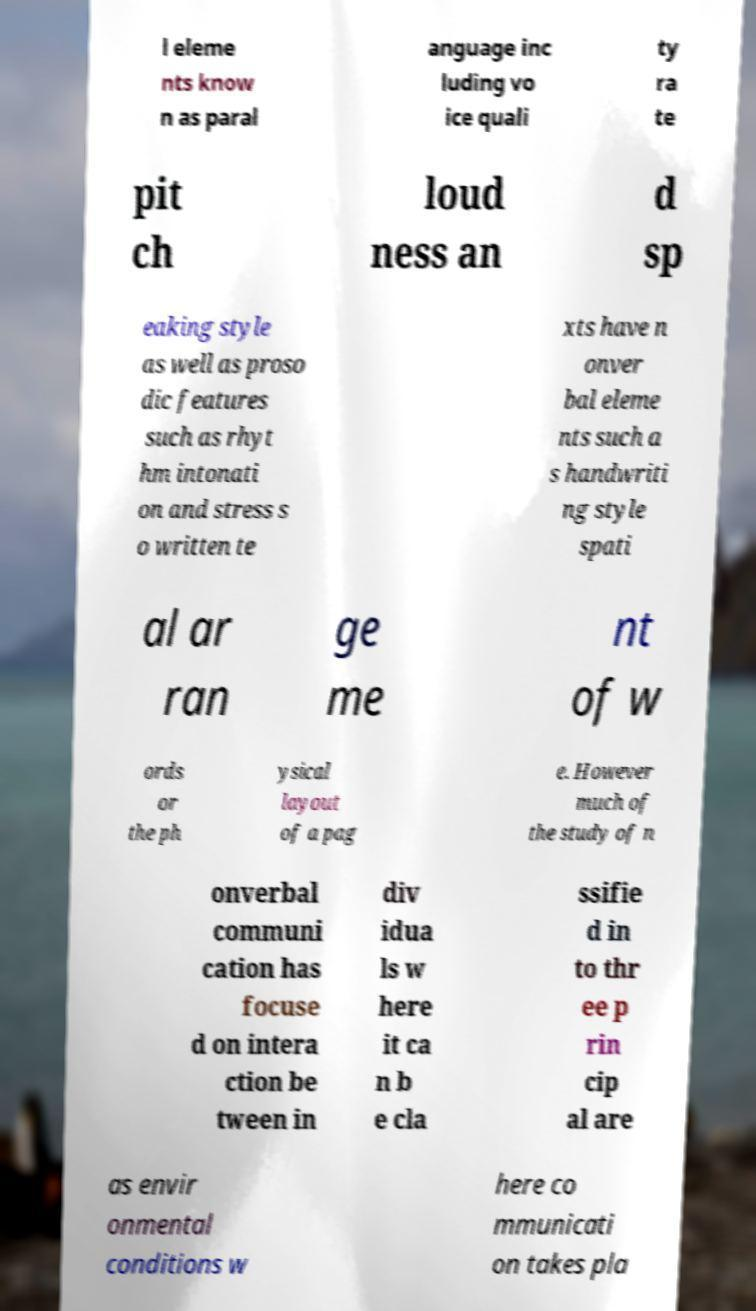Please read and relay the text visible in this image. What does it say? l eleme nts know n as paral anguage inc luding vo ice quali ty ra te pit ch loud ness an d sp eaking style as well as proso dic features such as rhyt hm intonati on and stress s o written te xts have n onver bal eleme nts such a s handwriti ng style spati al ar ran ge me nt of w ords or the ph ysical layout of a pag e. However much of the study of n onverbal communi cation has focuse d on intera ction be tween in div idua ls w here it ca n b e cla ssifie d in to thr ee p rin cip al are as envir onmental conditions w here co mmunicati on takes pla 